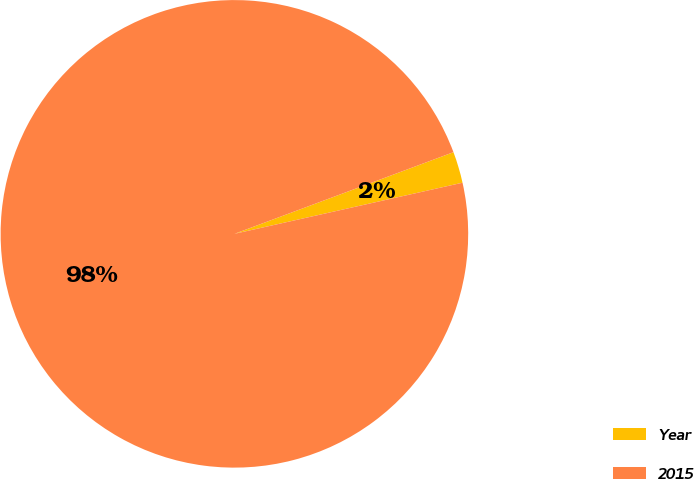Convert chart to OTSL. <chart><loc_0><loc_0><loc_500><loc_500><pie_chart><fcel>Year<fcel>2015<nl><fcel>2.17%<fcel>97.83%<nl></chart> 